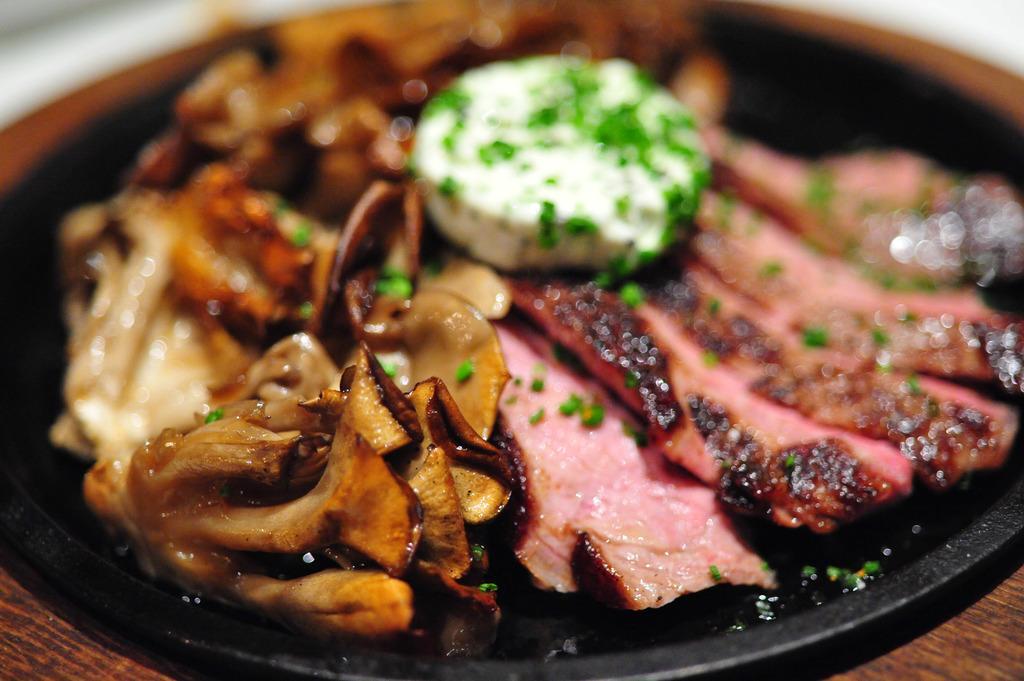How would you summarize this image in a sentence or two? This image consist of food which is on black colour pan. 